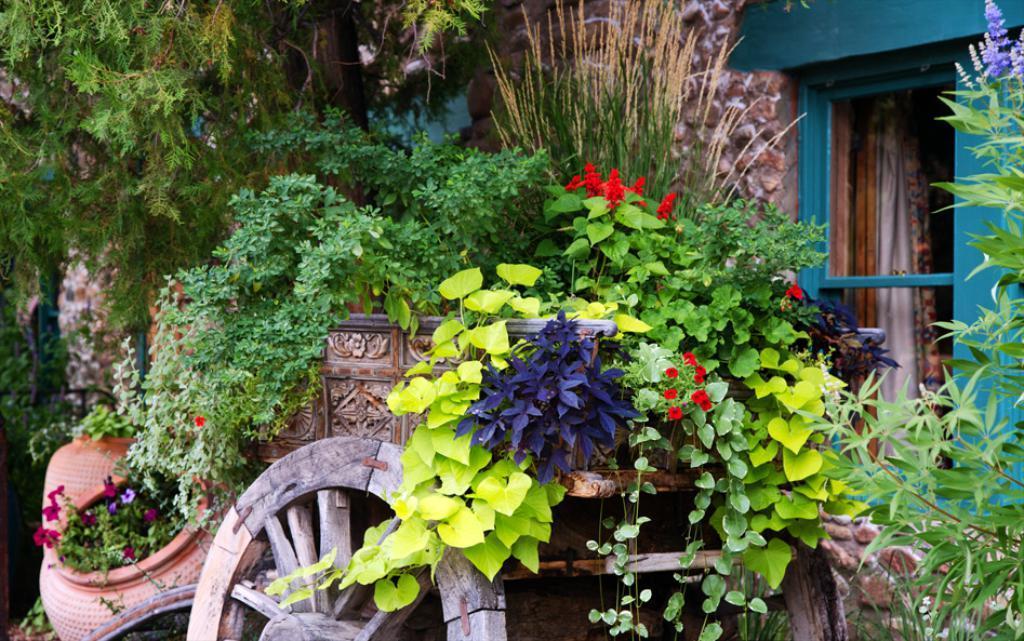Can you describe this image briefly? In this picture we can see a few plants and colorful flowers on a cart. We can see a building and a curtain is visible in the building. 